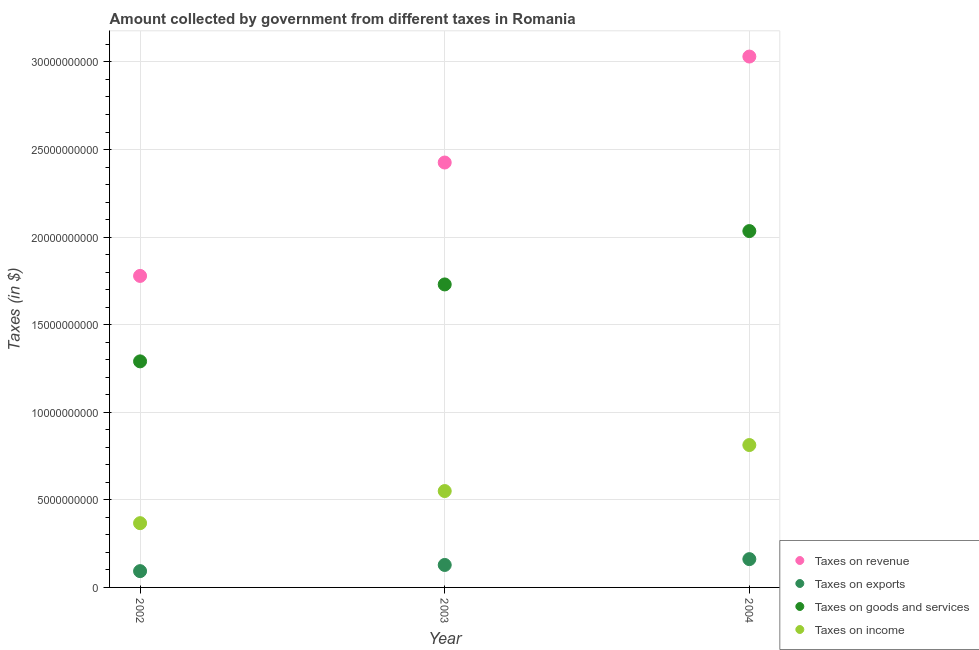Is the number of dotlines equal to the number of legend labels?
Keep it short and to the point. Yes. What is the amount collected as tax on revenue in 2004?
Provide a succinct answer. 3.03e+1. Across all years, what is the maximum amount collected as tax on revenue?
Ensure brevity in your answer.  3.03e+1. Across all years, what is the minimum amount collected as tax on exports?
Give a very brief answer. 9.30e+08. In which year was the amount collected as tax on exports minimum?
Ensure brevity in your answer.  2002. What is the total amount collected as tax on revenue in the graph?
Your answer should be compact. 7.24e+1. What is the difference between the amount collected as tax on exports in 2002 and that in 2004?
Offer a very short reply. -6.85e+08. What is the difference between the amount collected as tax on exports in 2002 and the amount collected as tax on revenue in 2004?
Keep it short and to the point. -2.94e+1. What is the average amount collected as tax on income per year?
Ensure brevity in your answer.  5.77e+09. In the year 2002, what is the difference between the amount collected as tax on revenue and amount collected as tax on goods?
Your answer should be very brief. 4.88e+09. In how many years, is the amount collected as tax on revenue greater than 1000000000 $?
Make the answer very short. 3. What is the ratio of the amount collected as tax on revenue in 2002 to that in 2003?
Your response must be concise. 0.73. What is the difference between the highest and the second highest amount collected as tax on revenue?
Give a very brief answer. 6.05e+09. What is the difference between the highest and the lowest amount collected as tax on exports?
Offer a terse response. 6.85e+08. Is it the case that in every year, the sum of the amount collected as tax on exports and amount collected as tax on goods is greater than the sum of amount collected as tax on income and amount collected as tax on revenue?
Provide a short and direct response. Yes. Is the amount collected as tax on revenue strictly greater than the amount collected as tax on income over the years?
Provide a short and direct response. Yes. How many dotlines are there?
Offer a terse response. 4. How many years are there in the graph?
Provide a succinct answer. 3. Where does the legend appear in the graph?
Offer a terse response. Bottom right. How many legend labels are there?
Your response must be concise. 4. What is the title of the graph?
Your answer should be compact. Amount collected by government from different taxes in Romania. Does "Energy" appear as one of the legend labels in the graph?
Your answer should be very brief. No. What is the label or title of the X-axis?
Ensure brevity in your answer.  Year. What is the label or title of the Y-axis?
Ensure brevity in your answer.  Taxes (in $). What is the Taxes (in $) in Taxes on revenue in 2002?
Offer a very short reply. 1.78e+1. What is the Taxes (in $) in Taxes on exports in 2002?
Your answer should be compact. 9.30e+08. What is the Taxes (in $) of Taxes on goods and services in 2002?
Keep it short and to the point. 1.29e+1. What is the Taxes (in $) in Taxes on income in 2002?
Your answer should be very brief. 3.67e+09. What is the Taxes (in $) of Taxes on revenue in 2003?
Keep it short and to the point. 2.43e+1. What is the Taxes (in $) of Taxes on exports in 2003?
Provide a short and direct response. 1.28e+09. What is the Taxes (in $) in Taxes on goods and services in 2003?
Offer a very short reply. 1.73e+1. What is the Taxes (in $) of Taxes on income in 2003?
Ensure brevity in your answer.  5.50e+09. What is the Taxes (in $) of Taxes on revenue in 2004?
Ensure brevity in your answer.  3.03e+1. What is the Taxes (in $) in Taxes on exports in 2004?
Offer a very short reply. 1.62e+09. What is the Taxes (in $) in Taxes on goods and services in 2004?
Your answer should be very brief. 2.03e+1. What is the Taxes (in $) in Taxes on income in 2004?
Your answer should be very brief. 8.13e+09. Across all years, what is the maximum Taxes (in $) of Taxes on revenue?
Offer a very short reply. 3.03e+1. Across all years, what is the maximum Taxes (in $) in Taxes on exports?
Ensure brevity in your answer.  1.62e+09. Across all years, what is the maximum Taxes (in $) in Taxes on goods and services?
Give a very brief answer. 2.03e+1. Across all years, what is the maximum Taxes (in $) in Taxes on income?
Provide a succinct answer. 8.13e+09. Across all years, what is the minimum Taxes (in $) of Taxes on revenue?
Give a very brief answer. 1.78e+1. Across all years, what is the minimum Taxes (in $) in Taxes on exports?
Provide a short and direct response. 9.30e+08. Across all years, what is the minimum Taxes (in $) of Taxes on goods and services?
Provide a succinct answer. 1.29e+1. Across all years, what is the minimum Taxes (in $) of Taxes on income?
Your response must be concise. 3.67e+09. What is the total Taxes (in $) in Taxes on revenue in the graph?
Keep it short and to the point. 7.24e+1. What is the total Taxes (in $) of Taxes on exports in the graph?
Offer a terse response. 3.83e+09. What is the total Taxes (in $) of Taxes on goods and services in the graph?
Make the answer very short. 5.05e+1. What is the total Taxes (in $) of Taxes on income in the graph?
Provide a short and direct response. 1.73e+1. What is the difference between the Taxes (in $) in Taxes on revenue in 2002 and that in 2003?
Keep it short and to the point. -6.47e+09. What is the difference between the Taxes (in $) of Taxes on exports in 2002 and that in 2003?
Offer a terse response. -3.53e+08. What is the difference between the Taxes (in $) in Taxes on goods and services in 2002 and that in 2003?
Make the answer very short. -4.39e+09. What is the difference between the Taxes (in $) of Taxes on income in 2002 and that in 2003?
Your response must be concise. -1.83e+09. What is the difference between the Taxes (in $) in Taxes on revenue in 2002 and that in 2004?
Offer a very short reply. -1.25e+1. What is the difference between the Taxes (in $) in Taxes on exports in 2002 and that in 2004?
Offer a very short reply. -6.85e+08. What is the difference between the Taxes (in $) in Taxes on goods and services in 2002 and that in 2004?
Offer a very short reply. -7.44e+09. What is the difference between the Taxes (in $) of Taxes on income in 2002 and that in 2004?
Provide a succinct answer. -4.46e+09. What is the difference between the Taxes (in $) in Taxes on revenue in 2003 and that in 2004?
Your response must be concise. -6.05e+09. What is the difference between the Taxes (in $) in Taxes on exports in 2003 and that in 2004?
Provide a succinct answer. -3.32e+08. What is the difference between the Taxes (in $) of Taxes on goods and services in 2003 and that in 2004?
Provide a short and direct response. -3.05e+09. What is the difference between the Taxes (in $) of Taxes on income in 2003 and that in 2004?
Keep it short and to the point. -2.63e+09. What is the difference between the Taxes (in $) of Taxes on revenue in 2002 and the Taxes (in $) of Taxes on exports in 2003?
Make the answer very short. 1.65e+1. What is the difference between the Taxes (in $) of Taxes on revenue in 2002 and the Taxes (in $) of Taxes on goods and services in 2003?
Your answer should be compact. 4.86e+08. What is the difference between the Taxes (in $) in Taxes on revenue in 2002 and the Taxes (in $) in Taxes on income in 2003?
Make the answer very short. 1.23e+1. What is the difference between the Taxes (in $) of Taxes on exports in 2002 and the Taxes (in $) of Taxes on goods and services in 2003?
Offer a terse response. -1.64e+1. What is the difference between the Taxes (in $) of Taxes on exports in 2002 and the Taxes (in $) of Taxes on income in 2003?
Your answer should be compact. -4.57e+09. What is the difference between the Taxes (in $) in Taxes on goods and services in 2002 and the Taxes (in $) in Taxes on income in 2003?
Your response must be concise. 7.40e+09. What is the difference between the Taxes (in $) of Taxes on revenue in 2002 and the Taxes (in $) of Taxes on exports in 2004?
Give a very brief answer. 1.62e+1. What is the difference between the Taxes (in $) of Taxes on revenue in 2002 and the Taxes (in $) of Taxes on goods and services in 2004?
Your answer should be compact. -2.56e+09. What is the difference between the Taxes (in $) in Taxes on revenue in 2002 and the Taxes (in $) in Taxes on income in 2004?
Keep it short and to the point. 9.66e+09. What is the difference between the Taxes (in $) of Taxes on exports in 2002 and the Taxes (in $) of Taxes on goods and services in 2004?
Your answer should be very brief. -1.94e+1. What is the difference between the Taxes (in $) in Taxes on exports in 2002 and the Taxes (in $) in Taxes on income in 2004?
Your answer should be compact. -7.20e+09. What is the difference between the Taxes (in $) of Taxes on goods and services in 2002 and the Taxes (in $) of Taxes on income in 2004?
Keep it short and to the point. 4.78e+09. What is the difference between the Taxes (in $) of Taxes on revenue in 2003 and the Taxes (in $) of Taxes on exports in 2004?
Offer a very short reply. 2.26e+1. What is the difference between the Taxes (in $) of Taxes on revenue in 2003 and the Taxes (in $) of Taxes on goods and services in 2004?
Offer a terse response. 3.91e+09. What is the difference between the Taxes (in $) of Taxes on revenue in 2003 and the Taxes (in $) of Taxes on income in 2004?
Your response must be concise. 1.61e+1. What is the difference between the Taxes (in $) of Taxes on exports in 2003 and the Taxes (in $) of Taxes on goods and services in 2004?
Offer a terse response. -1.91e+1. What is the difference between the Taxes (in $) in Taxes on exports in 2003 and the Taxes (in $) in Taxes on income in 2004?
Provide a short and direct response. -6.85e+09. What is the difference between the Taxes (in $) of Taxes on goods and services in 2003 and the Taxes (in $) of Taxes on income in 2004?
Provide a succinct answer. 9.17e+09. What is the average Taxes (in $) of Taxes on revenue per year?
Give a very brief answer. 2.41e+1. What is the average Taxes (in $) in Taxes on exports per year?
Your answer should be compact. 1.28e+09. What is the average Taxes (in $) of Taxes on goods and services per year?
Give a very brief answer. 1.68e+1. What is the average Taxes (in $) of Taxes on income per year?
Give a very brief answer. 5.77e+09. In the year 2002, what is the difference between the Taxes (in $) of Taxes on revenue and Taxes (in $) of Taxes on exports?
Ensure brevity in your answer.  1.69e+1. In the year 2002, what is the difference between the Taxes (in $) of Taxes on revenue and Taxes (in $) of Taxes on goods and services?
Ensure brevity in your answer.  4.88e+09. In the year 2002, what is the difference between the Taxes (in $) in Taxes on revenue and Taxes (in $) in Taxes on income?
Ensure brevity in your answer.  1.41e+1. In the year 2002, what is the difference between the Taxes (in $) of Taxes on exports and Taxes (in $) of Taxes on goods and services?
Provide a short and direct response. -1.20e+1. In the year 2002, what is the difference between the Taxes (in $) in Taxes on exports and Taxes (in $) in Taxes on income?
Keep it short and to the point. -2.74e+09. In the year 2002, what is the difference between the Taxes (in $) in Taxes on goods and services and Taxes (in $) in Taxes on income?
Make the answer very short. 9.24e+09. In the year 2003, what is the difference between the Taxes (in $) in Taxes on revenue and Taxes (in $) in Taxes on exports?
Offer a terse response. 2.30e+1. In the year 2003, what is the difference between the Taxes (in $) in Taxes on revenue and Taxes (in $) in Taxes on goods and services?
Your answer should be very brief. 6.96e+09. In the year 2003, what is the difference between the Taxes (in $) in Taxes on revenue and Taxes (in $) in Taxes on income?
Provide a short and direct response. 1.88e+1. In the year 2003, what is the difference between the Taxes (in $) in Taxes on exports and Taxes (in $) in Taxes on goods and services?
Your answer should be very brief. -1.60e+1. In the year 2003, what is the difference between the Taxes (in $) of Taxes on exports and Taxes (in $) of Taxes on income?
Provide a short and direct response. -4.22e+09. In the year 2003, what is the difference between the Taxes (in $) of Taxes on goods and services and Taxes (in $) of Taxes on income?
Offer a very short reply. 1.18e+1. In the year 2004, what is the difference between the Taxes (in $) in Taxes on revenue and Taxes (in $) in Taxes on exports?
Your answer should be very brief. 2.87e+1. In the year 2004, what is the difference between the Taxes (in $) of Taxes on revenue and Taxes (in $) of Taxes on goods and services?
Ensure brevity in your answer.  9.96e+09. In the year 2004, what is the difference between the Taxes (in $) of Taxes on revenue and Taxes (in $) of Taxes on income?
Your response must be concise. 2.22e+1. In the year 2004, what is the difference between the Taxes (in $) of Taxes on exports and Taxes (in $) of Taxes on goods and services?
Keep it short and to the point. -1.87e+1. In the year 2004, what is the difference between the Taxes (in $) in Taxes on exports and Taxes (in $) in Taxes on income?
Your answer should be very brief. -6.51e+09. In the year 2004, what is the difference between the Taxes (in $) in Taxes on goods and services and Taxes (in $) in Taxes on income?
Your answer should be very brief. 1.22e+1. What is the ratio of the Taxes (in $) in Taxes on revenue in 2002 to that in 2003?
Offer a terse response. 0.73. What is the ratio of the Taxes (in $) in Taxes on exports in 2002 to that in 2003?
Provide a succinct answer. 0.72. What is the ratio of the Taxes (in $) in Taxes on goods and services in 2002 to that in 2003?
Your answer should be compact. 0.75. What is the ratio of the Taxes (in $) of Taxes on income in 2002 to that in 2003?
Keep it short and to the point. 0.67. What is the ratio of the Taxes (in $) in Taxes on revenue in 2002 to that in 2004?
Your answer should be very brief. 0.59. What is the ratio of the Taxes (in $) in Taxes on exports in 2002 to that in 2004?
Make the answer very short. 0.58. What is the ratio of the Taxes (in $) of Taxes on goods and services in 2002 to that in 2004?
Your answer should be very brief. 0.63. What is the ratio of the Taxes (in $) in Taxes on income in 2002 to that in 2004?
Offer a very short reply. 0.45. What is the ratio of the Taxes (in $) of Taxes on revenue in 2003 to that in 2004?
Your answer should be very brief. 0.8. What is the ratio of the Taxes (in $) in Taxes on exports in 2003 to that in 2004?
Your answer should be very brief. 0.79. What is the ratio of the Taxes (in $) of Taxes on goods and services in 2003 to that in 2004?
Offer a terse response. 0.85. What is the ratio of the Taxes (in $) of Taxes on income in 2003 to that in 2004?
Your answer should be compact. 0.68. What is the difference between the highest and the second highest Taxes (in $) of Taxes on revenue?
Provide a succinct answer. 6.05e+09. What is the difference between the highest and the second highest Taxes (in $) in Taxes on exports?
Your response must be concise. 3.32e+08. What is the difference between the highest and the second highest Taxes (in $) in Taxes on goods and services?
Give a very brief answer. 3.05e+09. What is the difference between the highest and the second highest Taxes (in $) in Taxes on income?
Your response must be concise. 2.63e+09. What is the difference between the highest and the lowest Taxes (in $) in Taxes on revenue?
Offer a very short reply. 1.25e+1. What is the difference between the highest and the lowest Taxes (in $) of Taxes on exports?
Offer a very short reply. 6.85e+08. What is the difference between the highest and the lowest Taxes (in $) in Taxes on goods and services?
Your response must be concise. 7.44e+09. What is the difference between the highest and the lowest Taxes (in $) of Taxes on income?
Provide a short and direct response. 4.46e+09. 